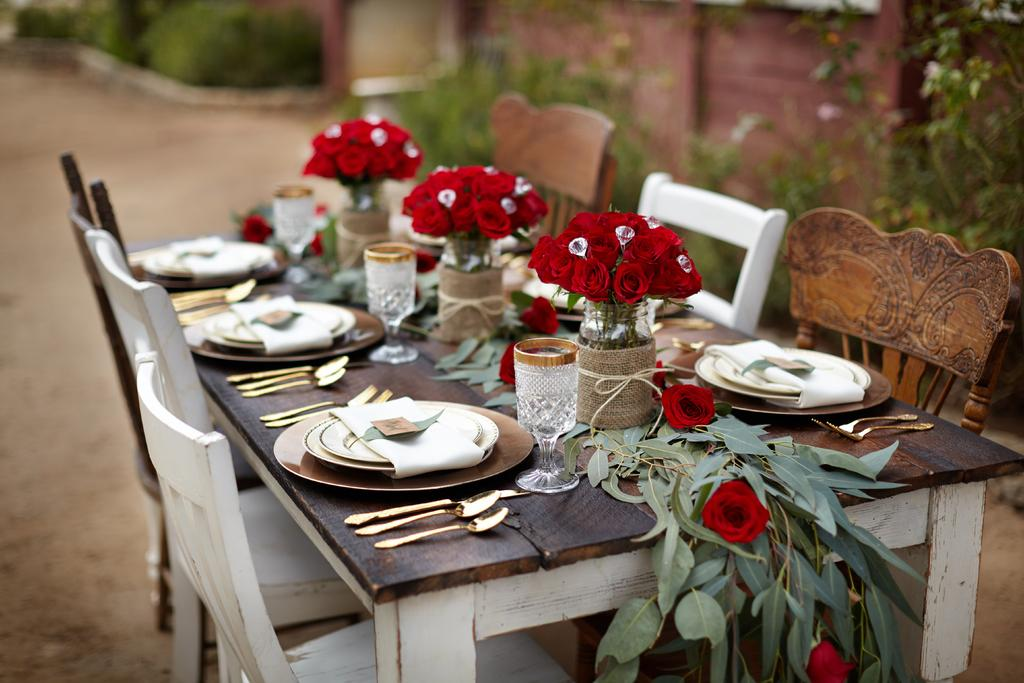What type of furniture is in the center of the image? There is a dining table in the image. What is positioned around the dining table? Chairs are surrounding the dining table. What decorative items can be seen on the dining table? There are 3 flower bouquets on the table. What tableware is present on the dining table? Plates with spoons and forks are present on the table, along with glasses. Where is the playground located in the image? There is no playground present in the image; it features a dining table with chairs and tableware. What type of creature is sitting on the scarecrow in the image? There is no scarecrow or creature present in the image. 